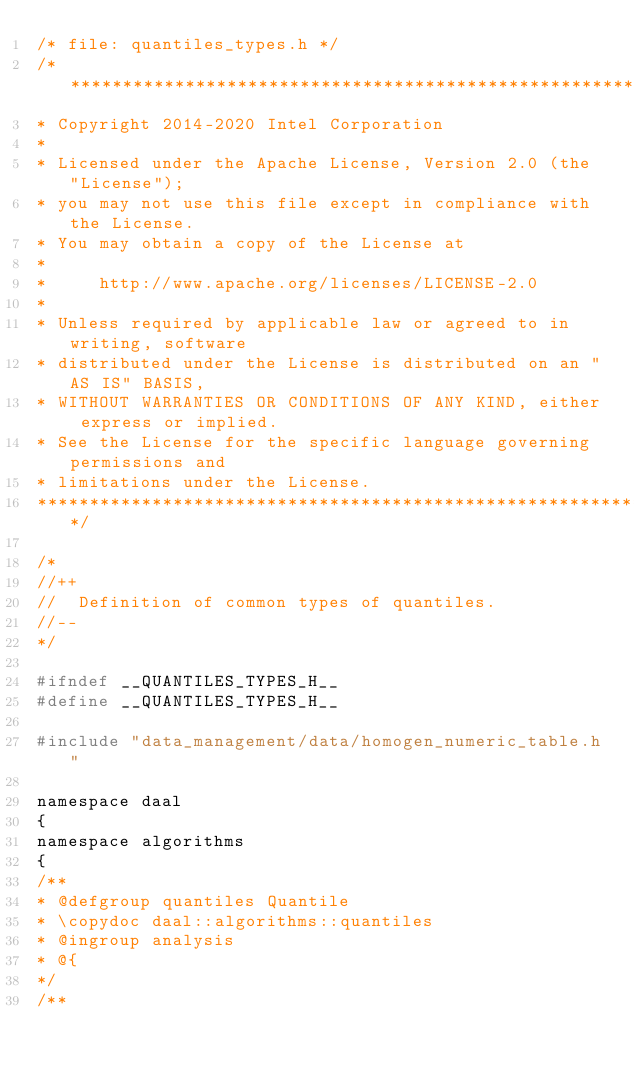Convert code to text. <code><loc_0><loc_0><loc_500><loc_500><_C_>/* file: quantiles_types.h */
/*******************************************************************************
* Copyright 2014-2020 Intel Corporation
*
* Licensed under the Apache License, Version 2.0 (the "License");
* you may not use this file except in compliance with the License.
* You may obtain a copy of the License at
*
*     http://www.apache.org/licenses/LICENSE-2.0
*
* Unless required by applicable law or agreed to in writing, software
* distributed under the License is distributed on an "AS IS" BASIS,
* WITHOUT WARRANTIES OR CONDITIONS OF ANY KIND, either express or implied.
* See the License for the specific language governing permissions and
* limitations under the License.
*******************************************************************************/

/*
//++
//  Definition of common types of quantiles.
//--
*/

#ifndef __QUANTILES_TYPES_H__
#define __QUANTILES_TYPES_H__

#include "data_management/data/homogen_numeric_table.h"

namespace daal
{
namespace algorithms
{
/**
* @defgroup quantiles Quantile
* \copydoc daal::algorithms::quantiles
* @ingroup analysis
* @{
*/
/**</code> 